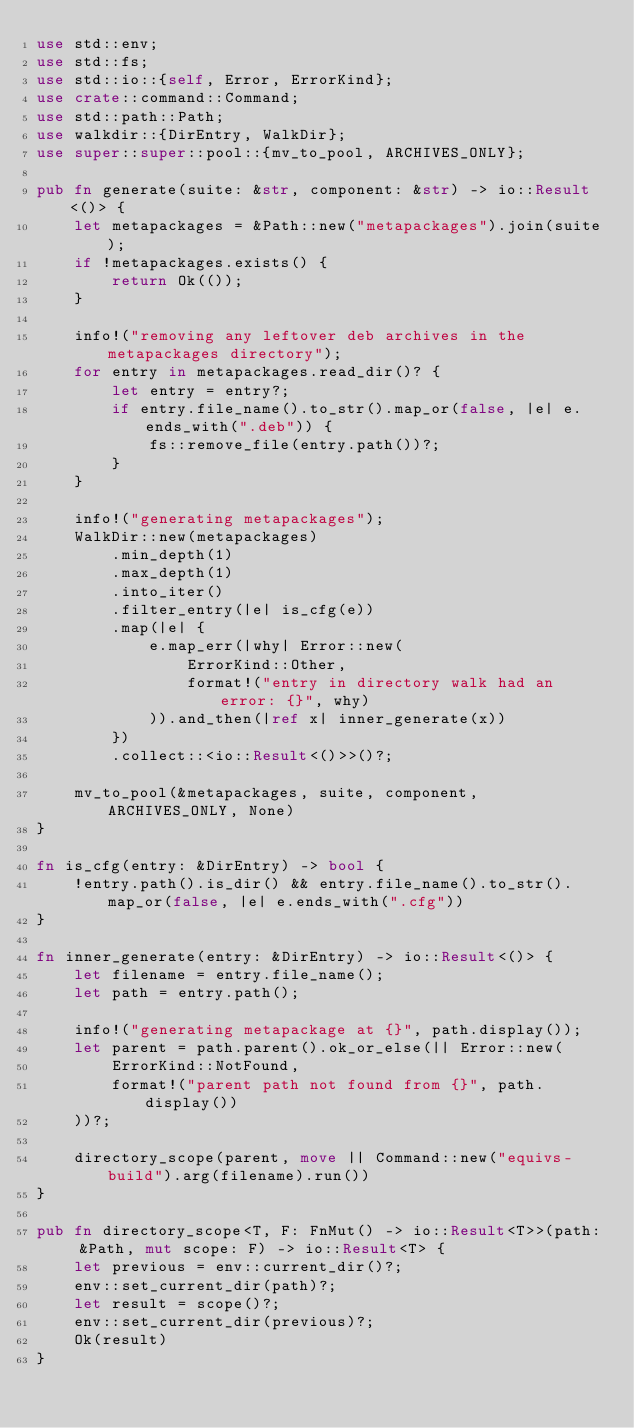Convert code to text. <code><loc_0><loc_0><loc_500><loc_500><_Rust_>use std::env;
use std::fs;
use std::io::{self, Error, ErrorKind};
use crate::command::Command;
use std::path::Path;
use walkdir::{DirEntry, WalkDir};
use super::super::pool::{mv_to_pool, ARCHIVES_ONLY};

pub fn generate(suite: &str, component: &str) -> io::Result<()> {
    let metapackages = &Path::new("metapackages").join(suite);
    if !metapackages.exists() {
        return Ok(());
    }

    info!("removing any leftover deb archives in the metapackages directory");
    for entry in metapackages.read_dir()? {
        let entry = entry?;
        if entry.file_name().to_str().map_or(false, |e| e.ends_with(".deb")) {
            fs::remove_file(entry.path())?;
        }
    }

    info!("generating metapackages");
    WalkDir::new(metapackages)
        .min_depth(1)
        .max_depth(1)
        .into_iter()
        .filter_entry(|e| is_cfg(e))
        .map(|e| {
            e.map_err(|why| Error::new(
                ErrorKind::Other,
                format!("entry in directory walk had an error: {}", why)
            )).and_then(|ref x| inner_generate(x))
        })
        .collect::<io::Result<()>>()?;

    mv_to_pool(&metapackages, suite, component, ARCHIVES_ONLY, None)
}

fn is_cfg(entry: &DirEntry) -> bool {
    !entry.path().is_dir() && entry.file_name().to_str().map_or(false, |e| e.ends_with(".cfg"))
}

fn inner_generate(entry: &DirEntry) -> io::Result<()> {
    let filename = entry.file_name();
    let path = entry.path();

    info!("generating metapackage at {}", path.display());
    let parent = path.parent().ok_or_else(|| Error::new(
        ErrorKind::NotFound,
        format!("parent path not found from {}", path.display())
    ))?;

    directory_scope(parent, move || Command::new("equivs-build").arg(filename).run())
}

pub fn directory_scope<T, F: FnMut() -> io::Result<T>>(path: &Path, mut scope: F) -> io::Result<T> {
    let previous = env::current_dir()?;
    env::set_current_dir(path)?;
    let result = scope()?;
    env::set_current_dir(previous)?;
    Ok(result)
}
</code> 